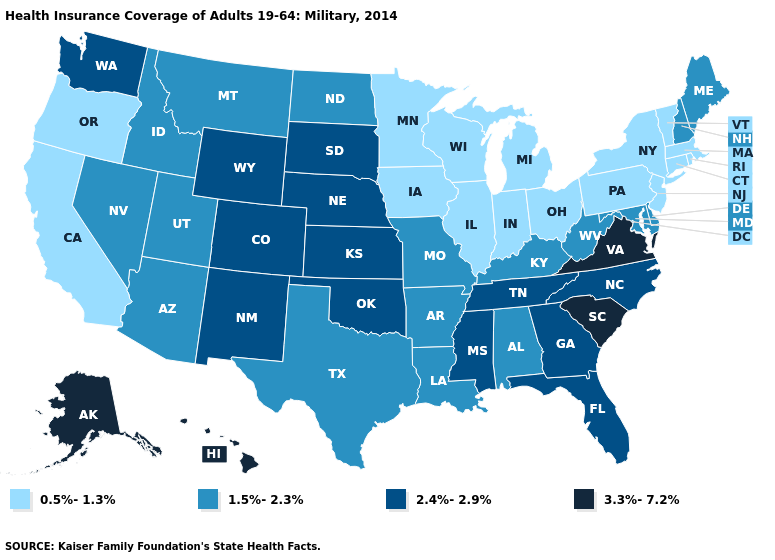Name the states that have a value in the range 3.3%-7.2%?
Concise answer only. Alaska, Hawaii, South Carolina, Virginia. Name the states that have a value in the range 2.4%-2.9%?
Short answer required. Colorado, Florida, Georgia, Kansas, Mississippi, Nebraska, New Mexico, North Carolina, Oklahoma, South Dakota, Tennessee, Washington, Wyoming. What is the value of South Carolina?
Concise answer only. 3.3%-7.2%. Does Vermont have the lowest value in the USA?
Quick response, please. Yes. Name the states that have a value in the range 1.5%-2.3%?
Quick response, please. Alabama, Arizona, Arkansas, Delaware, Idaho, Kentucky, Louisiana, Maine, Maryland, Missouri, Montana, Nevada, New Hampshire, North Dakota, Texas, Utah, West Virginia. Name the states that have a value in the range 2.4%-2.9%?
Answer briefly. Colorado, Florida, Georgia, Kansas, Mississippi, Nebraska, New Mexico, North Carolina, Oklahoma, South Dakota, Tennessee, Washington, Wyoming. What is the value of Massachusetts?
Keep it brief. 0.5%-1.3%. Name the states that have a value in the range 3.3%-7.2%?
Write a very short answer. Alaska, Hawaii, South Carolina, Virginia. Does Nevada have the highest value in the West?
Be succinct. No. Does Alaska have the lowest value in the USA?
Concise answer only. No. Does Alaska have the highest value in the USA?
Keep it brief. Yes. Does Iowa have a lower value than South Carolina?
Keep it brief. Yes. Does the first symbol in the legend represent the smallest category?
Be succinct. Yes. Among the states that border California , which have the lowest value?
Write a very short answer. Oregon. Which states have the lowest value in the South?
Be succinct. Alabama, Arkansas, Delaware, Kentucky, Louisiana, Maryland, Texas, West Virginia. 